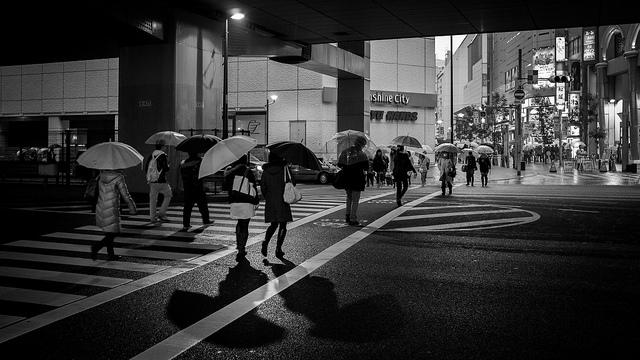How many lights are on in the tunnel?
Short answer required. 2. Are the umbrellas open?
Short answer required. Yes. Is this picture blurry?
Be succinct. No. Is it raining?
Give a very brief answer. Yes. When was this scene photographed?
Short answer required. Night. 